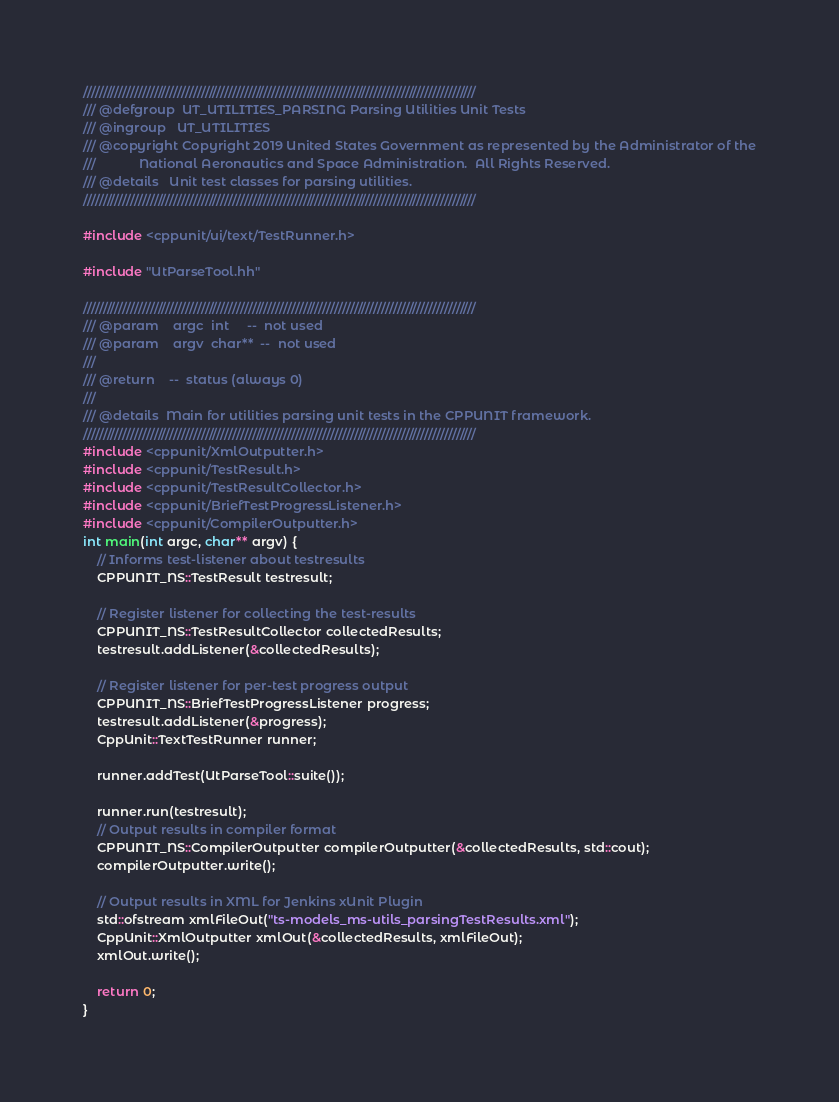<code> <loc_0><loc_0><loc_500><loc_500><_C++_>////////////////////////////////////////////////////////////////////////////////////////////////////
/// @defgroup  UT_UTILITIES_PARSING Parsing Utilities Unit Tests
/// @ingroup   UT_UTILITIES
/// @copyright Copyright 2019 United States Government as represented by the Administrator of the
///            National Aeronautics and Space Administration.  All Rights Reserved.
/// @details   Unit test classes for parsing utilities.
////////////////////////////////////////////////////////////////////////////////////////////////////

#include <cppunit/ui/text/TestRunner.h>

#include "UtParseTool.hh"

////////////////////////////////////////////////////////////////////////////////////////////////////
/// @param    argc  int     --  not used
/// @param    argv  char**  --  not used
///
/// @return    --  status (always 0)
///
/// @details  Main for utilities parsing unit tests in the CPPUNIT framework.
////////////////////////////////////////////////////////////////////////////////////////////////////
#include <cppunit/XmlOutputter.h>
#include <cppunit/TestResult.h>
#include <cppunit/TestResultCollector.h>
#include <cppunit/BriefTestProgressListener.h>
#include <cppunit/CompilerOutputter.h>
int main(int argc, char** argv) {
    // Informs test-listener about testresults
    CPPUNIT_NS::TestResult testresult;

    // Register listener for collecting the test-results
    CPPUNIT_NS::TestResultCollector collectedResults;
    testresult.addListener(&collectedResults);

    // Register listener for per-test progress output
    CPPUNIT_NS::BriefTestProgressListener progress;
    testresult.addListener(&progress);
    CppUnit::TextTestRunner runner;

    runner.addTest(UtParseTool::suite());

    runner.run(testresult);
    // Output results in compiler format
    CPPUNIT_NS::CompilerOutputter compilerOutputter(&collectedResults, std::cout);
    compilerOutputter.write();

    // Output results in XML for Jenkins xUnit Plugin
    std::ofstream xmlFileOut("ts-models_ms-utils_parsingTestResults.xml");
    CppUnit::XmlOutputter xmlOut(&collectedResults, xmlFileOut);
    xmlOut.write();

    return 0;
}

</code> 